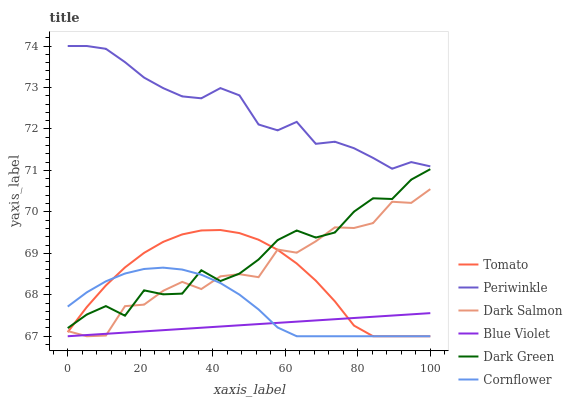Does Blue Violet have the minimum area under the curve?
Answer yes or no. Yes. Does Periwinkle have the maximum area under the curve?
Answer yes or no. Yes. Does Cornflower have the minimum area under the curve?
Answer yes or no. No. Does Cornflower have the maximum area under the curve?
Answer yes or no. No. Is Blue Violet the smoothest?
Answer yes or no. Yes. Is Dark Green the roughest?
Answer yes or no. Yes. Is Cornflower the smoothest?
Answer yes or no. No. Is Cornflower the roughest?
Answer yes or no. No. Does Tomato have the lowest value?
Answer yes or no. Yes. Does Periwinkle have the lowest value?
Answer yes or no. No. Does Periwinkle have the highest value?
Answer yes or no. Yes. Does Cornflower have the highest value?
Answer yes or no. No. Is Dark Green less than Periwinkle?
Answer yes or no. Yes. Is Periwinkle greater than Tomato?
Answer yes or no. Yes. Does Dark Salmon intersect Tomato?
Answer yes or no. Yes. Is Dark Salmon less than Tomato?
Answer yes or no. No. Is Dark Salmon greater than Tomato?
Answer yes or no. No. Does Dark Green intersect Periwinkle?
Answer yes or no. No. 